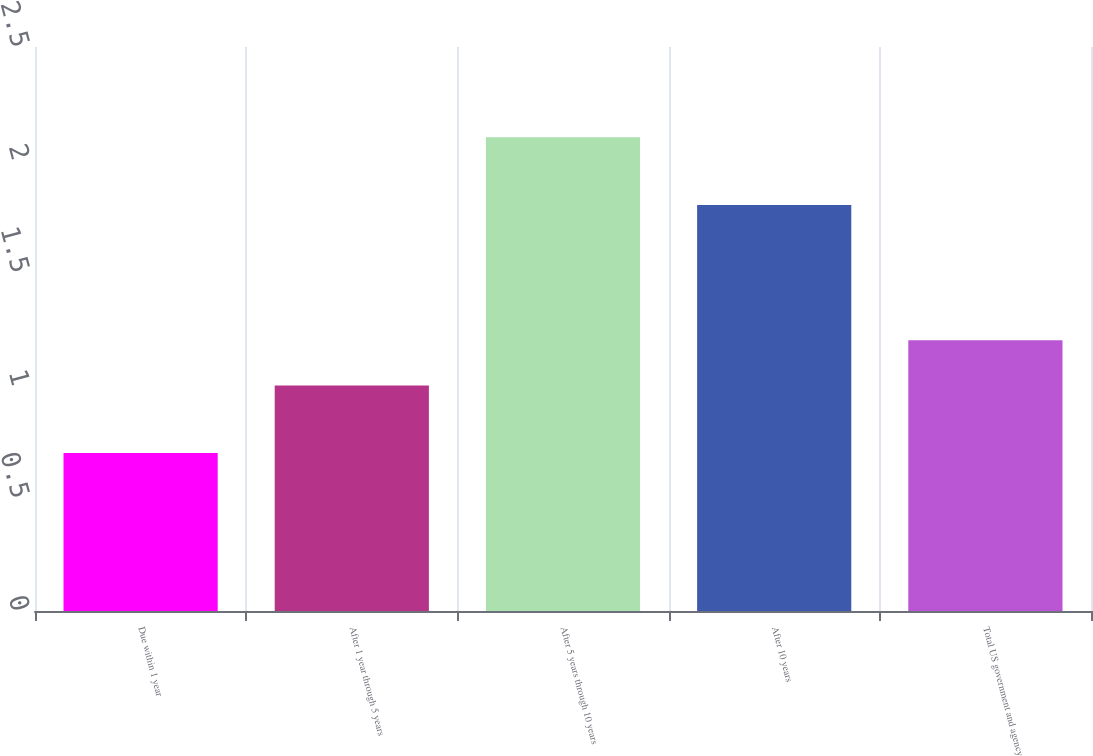Convert chart to OTSL. <chart><loc_0><loc_0><loc_500><loc_500><bar_chart><fcel>Due within 1 year<fcel>After 1 year through 5 years<fcel>After 5 years through 10 years<fcel>After 10 years<fcel>Total US government and agency<nl><fcel>0.7<fcel>1<fcel>2.1<fcel>1.8<fcel>1.2<nl></chart> 